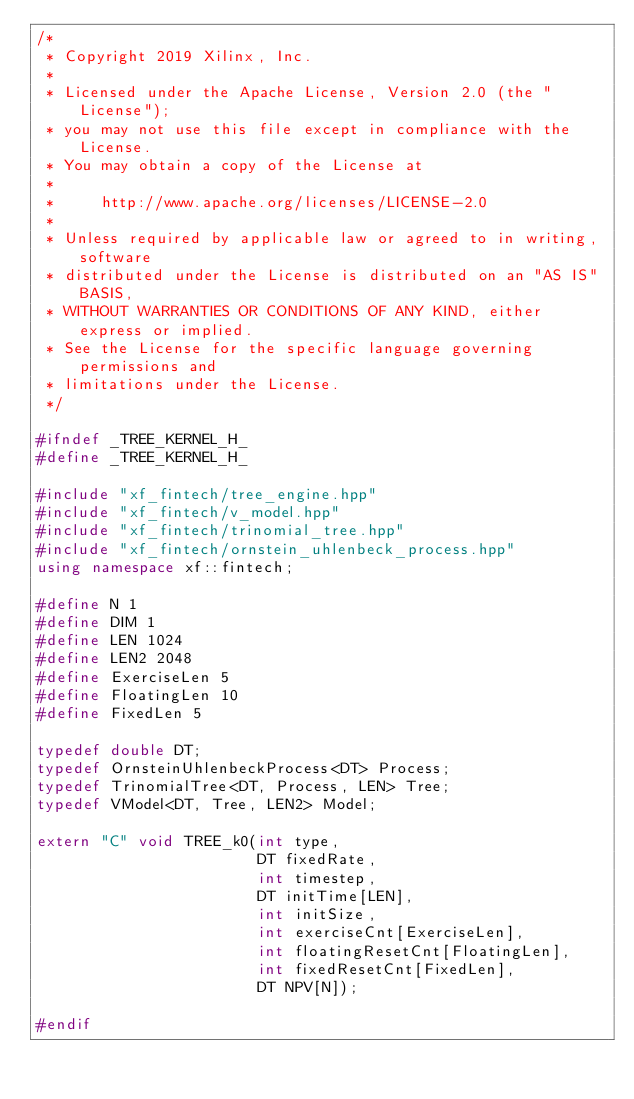Convert code to text. <code><loc_0><loc_0><loc_500><loc_500><_C++_>/*
 * Copyright 2019 Xilinx, Inc.
 *
 * Licensed under the Apache License, Version 2.0 (the "License");
 * you may not use this file except in compliance with the License.
 * You may obtain a copy of the License at
 *
 *     http://www.apache.org/licenses/LICENSE-2.0
 *
 * Unless required by applicable law or agreed to in writing, software
 * distributed under the License is distributed on an "AS IS" BASIS,
 * WITHOUT WARRANTIES OR CONDITIONS OF ANY KIND, either express or implied.
 * See the License for the specific language governing permissions and
 * limitations under the License.
 */

#ifndef _TREE_KERNEL_H_
#define _TREE_KERNEL_H_

#include "xf_fintech/tree_engine.hpp"
#include "xf_fintech/v_model.hpp"
#include "xf_fintech/trinomial_tree.hpp"
#include "xf_fintech/ornstein_uhlenbeck_process.hpp"
using namespace xf::fintech;

#define N 1
#define DIM 1
#define LEN 1024
#define LEN2 2048
#define ExerciseLen 5
#define FloatingLen 10
#define FixedLen 5

typedef double DT;
typedef OrnsteinUhlenbeckProcess<DT> Process;
typedef TrinomialTree<DT, Process, LEN> Tree;
typedef VModel<DT, Tree, LEN2> Model;

extern "C" void TREE_k0(int type,
                        DT fixedRate,
                        int timestep,
                        DT initTime[LEN],
                        int initSize,
                        int exerciseCnt[ExerciseLen],
                        int floatingResetCnt[FloatingLen],
                        int fixedResetCnt[FixedLen],
                        DT NPV[N]);

#endif
</code> 